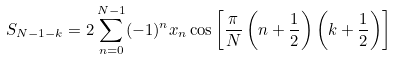Convert formula to latex. <formula><loc_0><loc_0><loc_500><loc_500>S _ { N - 1 - k } = 2 \sum _ { n = 0 } ^ { N - 1 } ( - 1 ) ^ { n } x _ { n } \cos \left [ \frac { \pi } { N } \left ( n + \frac { 1 } { 2 } \right ) \left ( k + \frac { 1 } { 2 } \right ) \right ]</formula> 